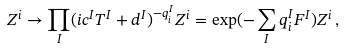<formula> <loc_0><loc_0><loc_500><loc_500>Z ^ { i } \to \prod _ { I } ( i c ^ { I } T ^ { I } + d ^ { I } ) ^ { - q _ { i } ^ { I } } Z ^ { i } = \exp ( - \sum _ { I } q ^ { I } _ { i } F ^ { I } ) Z ^ { i } \, ,</formula> 